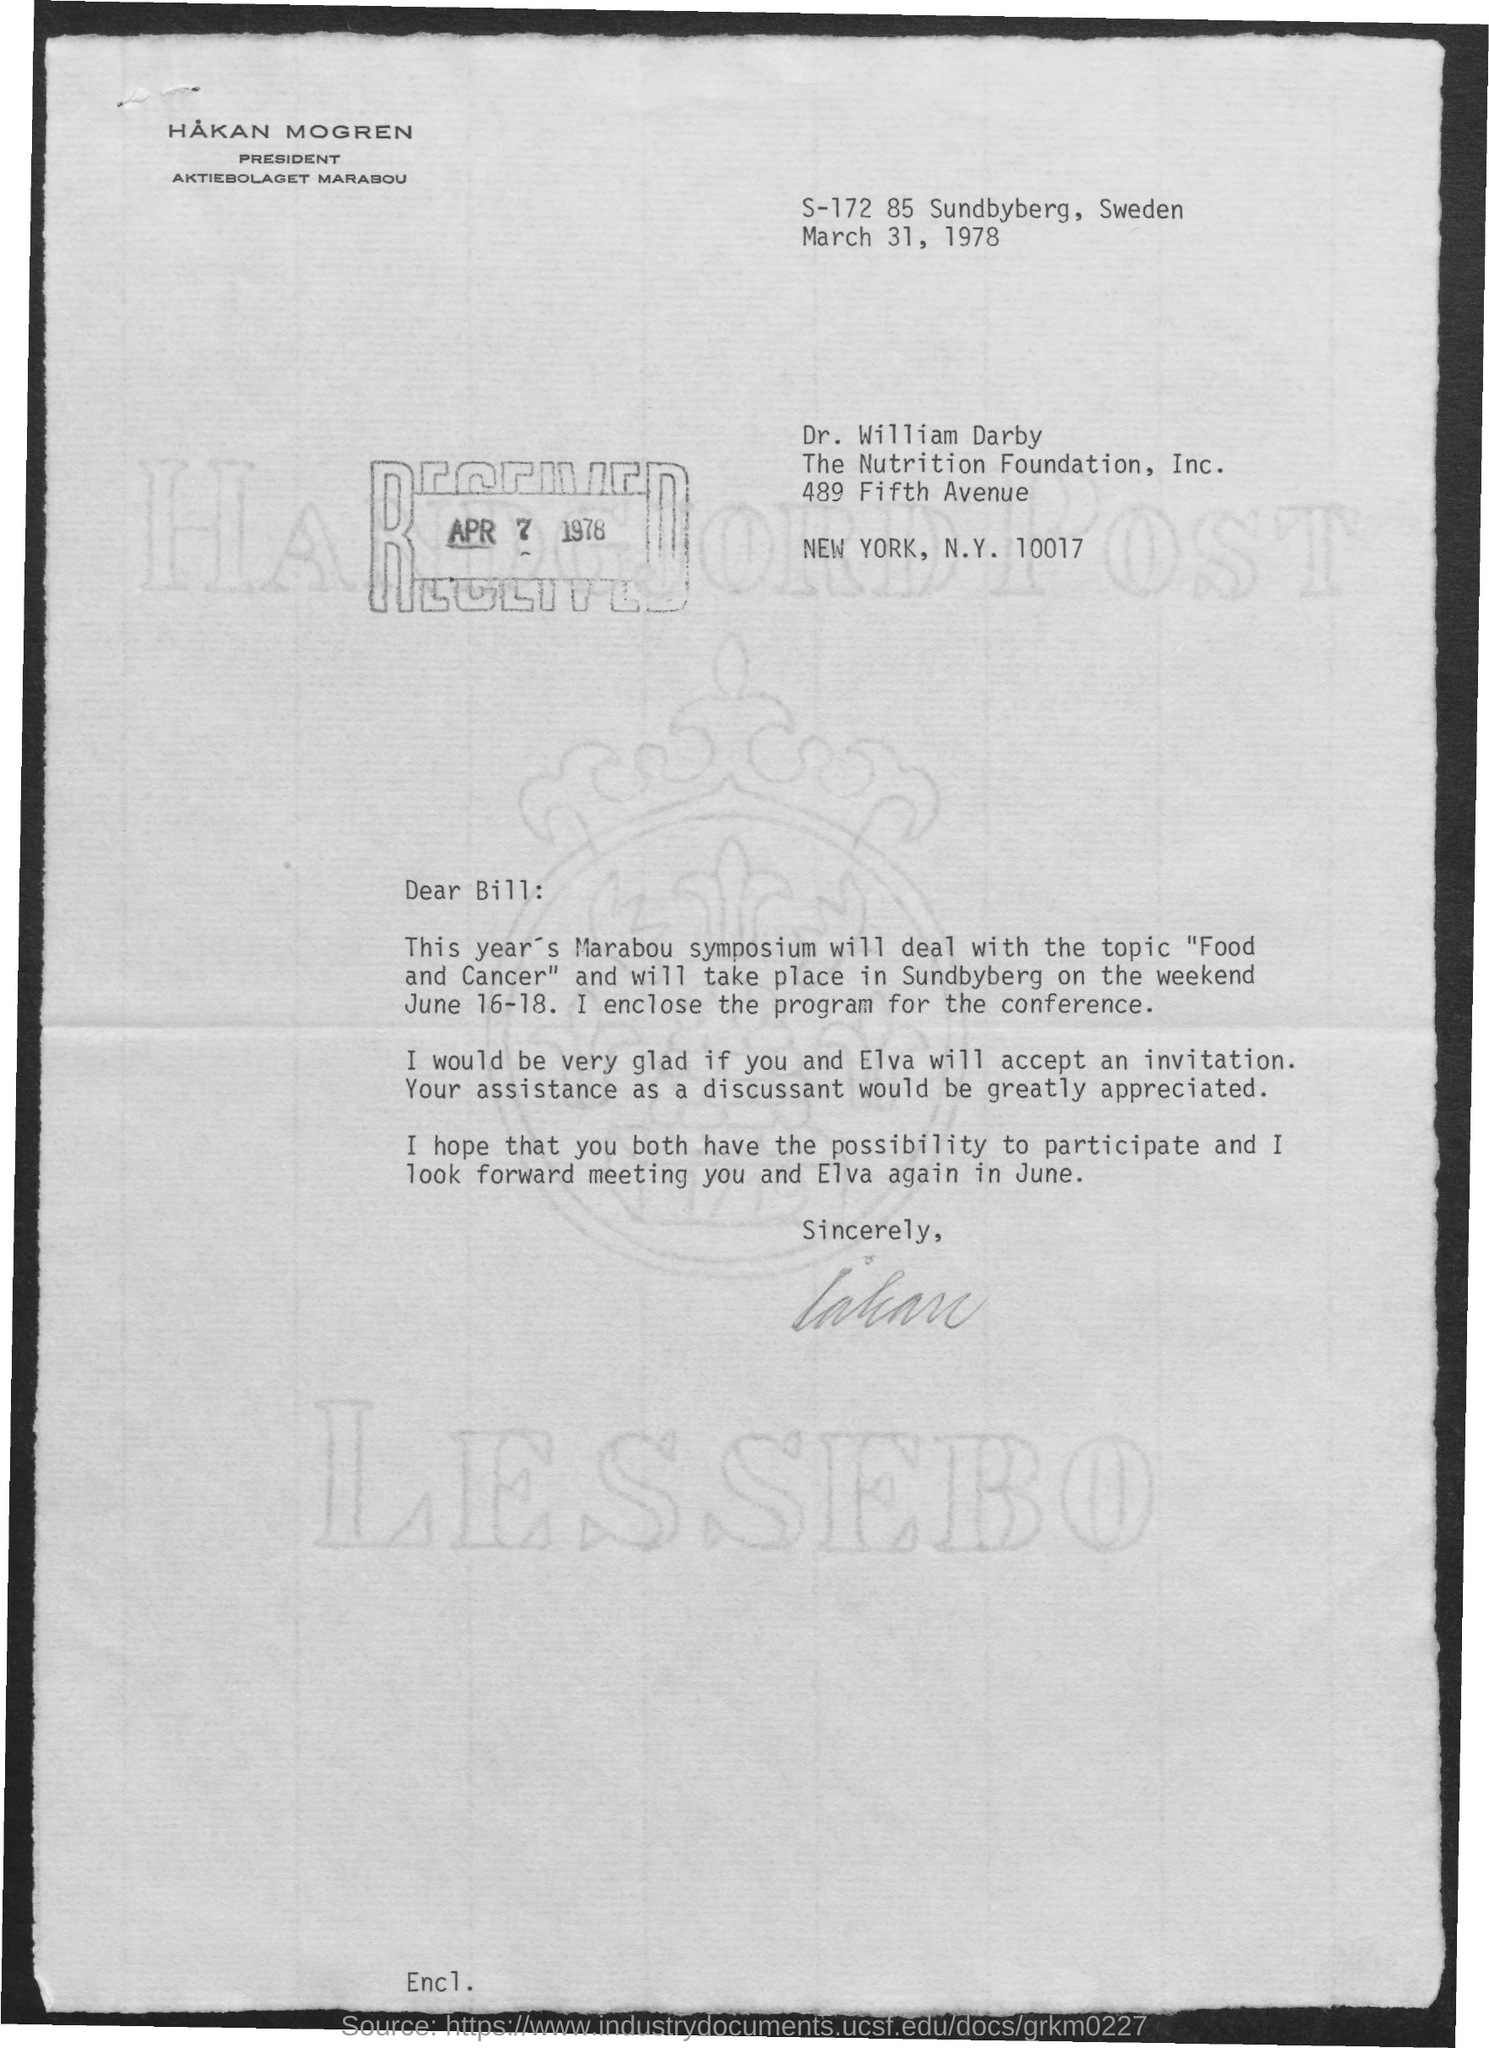What is topic of the symposium of this year?
Provide a short and direct response. "Food and Cancer". 